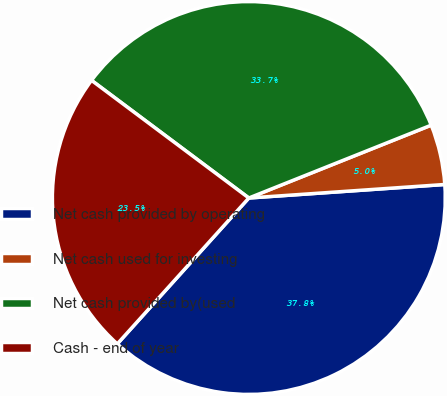Convert chart. <chart><loc_0><loc_0><loc_500><loc_500><pie_chart><fcel>Net cash provided by operating<fcel>Net cash used for investing<fcel>Net cash provided by(used<fcel>Cash - end of year<nl><fcel>37.77%<fcel>4.95%<fcel>33.73%<fcel>23.54%<nl></chart> 